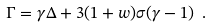<formula> <loc_0><loc_0><loc_500><loc_500>\Gamma = \gamma \Delta + 3 ( 1 + w ) \sigma ( \gamma - 1 ) \ .</formula> 